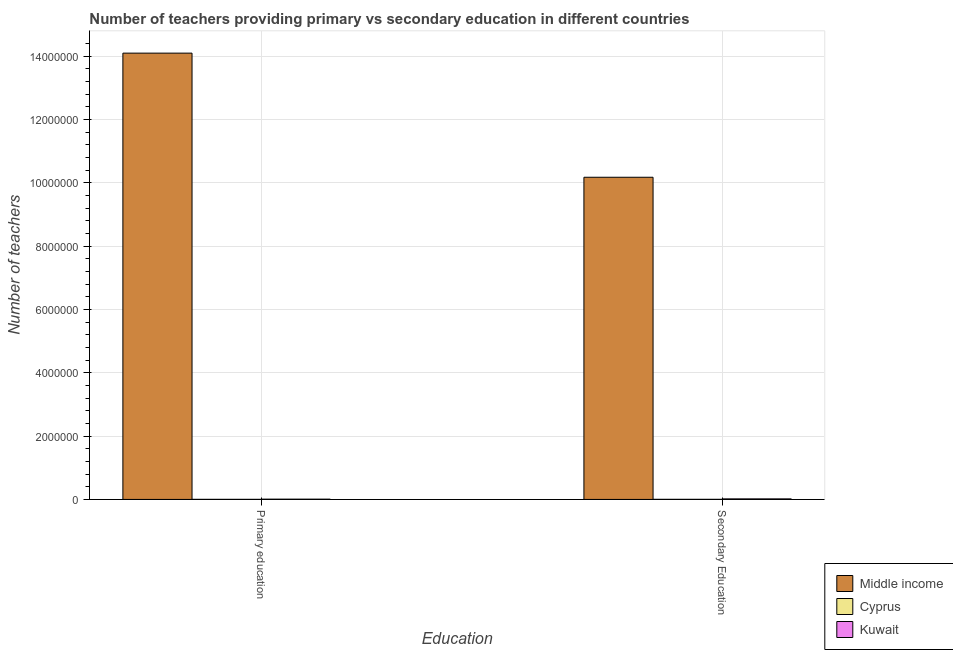How many different coloured bars are there?
Make the answer very short. 3. Are the number of bars per tick equal to the number of legend labels?
Provide a succinct answer. Yes. What is the label of the 2nd group of bars from the left?
Make the answer very short. Secondary Education. What is the number of secondary teachers in Kuwait?
Your answer should be very brief. 1.72e+04. Across all countries, what is the maximum number of secondary teachers?
Give a very brief answer. 1.02e+07. Across all countries, what is the minimum number of primary teachers?
Provide a succinct answer. 2221. In which country was the number of secondary teachers minimum?
Your response must be concise. Cyprus. What is the total number of secondary teachers in the graph?
Offer a terse response. 1.02e+07. What is the difference between the number of primary teachers in Kuwait and that in Middle income?
Provide a succinct answer. -1.41e+07. What is the difference between the number of secondary teachers in Cyprus and the number of primary teachers in Middle income?
Your answer should be very brief. -1.41e+07. What is the average number of primary teachers per country?
Your answer should be very brief. 4.70e+06. What is the difference between the number of primary teachers and number of secondary teachers in Kuwait?
Ensure brevity in your answer.  -8809. What is the ratio of the number of secondary teachers in Middle income to that in Kuwait?
Provide a succinct answer. 593.13. Is the number of primary teachers in Middle income less than that in Kuwait?
Provide a short and direct response. No. In how many countries, is the number of secondary teachers greater than the average number of secondary teachers taken over all countries?
Your answer should be very brief. 1. What does the 1st bar from the left in Secondary Education represents?
Your response must be concise. Middle income. What does the 2nd bar from the right in Primary education represents?
Ensure brevity in your answer.  Cyprus. How many bars are there?
Make the answer very short. 6. Are all the bars in the graph horizontal?
Your answer should be compact. No. Does the graph contain grids?
Offer a terse response. Yes. How many legend labels are there?
Your answer should be compact. 3. What is the title of the graph?
Provide a short and direct response. Number of teachers providing primary vs secondary education in different countries. Does "New Caledonia" appear as one of the legend labels in the graph?
Offer a very short reply. No. What is the label or title of the X-axis?
Your answer should be compact. Education. What is the label or title of the Y-axis?
Ensure brevity in your answer.  Number of teachers. What is the Number of teachers in Middle income in Primary education?
Your response must be concise. 1.41e+07. What is the Number of teachers of Cyprus in Primary education?
Offer a terse response. 2221. What is the Number of teachers in Kuwait in Primary education?
Your answer should be very brief. 8346. What is the Number of teachers in Middle income in Secondary Education?
Your answer should be compact. 1.02e+07. What is the Number of teachers in Cyprus in Secondary Education?
Provide a succinct answer. 3093. What is the Number of teachers of Kuwait in Secondary Education?
Your response must be concise. 1.72e+04. Across all Education, what is the maximum Number of teachers in Middle income?
Your answer should be very brief. 1.41e+07. Across all Education, what is the maximum Number of teachers of Cyprus?
Your response must be concise. 3093. Across all Education, what is the maximum Number of teachers in Kuwait?
Your response must be concise. 1.72e+04. Across all Education, what is the minimum Number of teachers of Middle income?
Provide a succinct answer. 1.02e+07. Across all Education, what is the minimum Number of teachers in Cyprus?
Offer a terse response. 2221. Across all Education, what is the minimum Number of teachers of Kuwait?
Ensure brevity in your answer.  8346. What is the total Number of teachers of Middle income in the graph?
Provide a short and direct response. 2.43e+07. What is the total Number of teachers of Cyprus in the graph?
Ensure brevity in your answer.  5314. What is the total Number of teachers of Kuwait in the graph?
Your answer should be very brief. 2.55e+04. What is the difference between the Number of teachers of Middle income in Primary education and that in Secondary Education?
Offer a very short reply. 3.92e+06. What is the difference between the Number of teachers of Cyprus in Primary education and that in Secondary Education?
Offer a terse response. -872. What is the difference between the Number of teachers of Kuwait in Primary education and that in Secondary Education?
Offer a terse response. -8809. What is the difference between the Number of teachers of Middle income in Primary education and the Number of teachers of Cyprus in Secondary Education?
Make the answer very short. 1.41e+07. What is the difference between the Number of teachers of Middle income in Primary education and the Number of teachers of Kuwait in Secondary Education?
Give a very brief answer. 1.41e+07. What is the difference between the Number of teachers of Cyprus in Primary education and the Number of teachers of Kuwait in Secondary Education?
Offer a very short reply. -1.49e+04. What is the average Number of teachers in Middle income per Education?
Your response must be concise. 1.21e+07. What is the average Number of teachers of Cyprus per Education?
Offer a very short reply. 2657. What is the average Number of teachers in Kuwait per Education?
Your response must be concise. 1.28e+04. What is the difference between the Number of teachers in Middle income and Number of teachers in Cyprus in Primary education?
Offer a terse response. 1.41e+07. What is the difference between the Number of teachers of Middle income and Number of teachers of Kuwait in Primary education?
Your response must be concise. 1.41e+07. What is the difference between the Number of teachers in Cyprus and Number of teachers in Kuwait in Primary education?
Offer a terse response. -6125. What is the difference between the Number of teachers in Middle income and Number of teachers in Cyprus in Secondary Education?
Ensure brevity in your answer.  1.02e+07. What is the difference between the Number of teachers of Middle income and Number of teachers of Kuwait in Secondary Education?
Offer a terse response. 1.02e+07. What is the difference between the Number of teachers in Cyprus and Number of teachers in Kuwait in Secondary Education?
Offer a terse response. -1.41e+04. What is the ratio of the Number of teachers in Middle income in Primary education to that in Secondary Education?
Provide a succinct answer. 1.39. What is the ratio of the Number of teachers of Cyprus in Primary education to that in Secondary Education?
Provide a short and direct response. 0.72. What is the ratio of the Number of teachers of Kuwait in Primary education to that in Secondary Education?
Give a very brief answer. 0.49. What is the difference between the highest and the second highest Number of teachers of Middle income?
Make the answer very short. 3.92e+06. What is the difference between the highest and the second highest Number of teachers in Cyprus?
Make the answer very short. 872. What is the difference between the highest and the second highest Number of teachers in Kuwait?
Your answer should be very brief. 8809. What is the difference between the highest and the lowest Number of teachers in Middle income?
Ensure brevity in your answer.  3.92e+06. What is the difference between the highest and the lowest Number of teachers of Cyprus?
Your answer should be very brief. 872. What is the difference between the highest and the lowest Number of teachers in Kuwait?
Your response must be concise. 8809. 